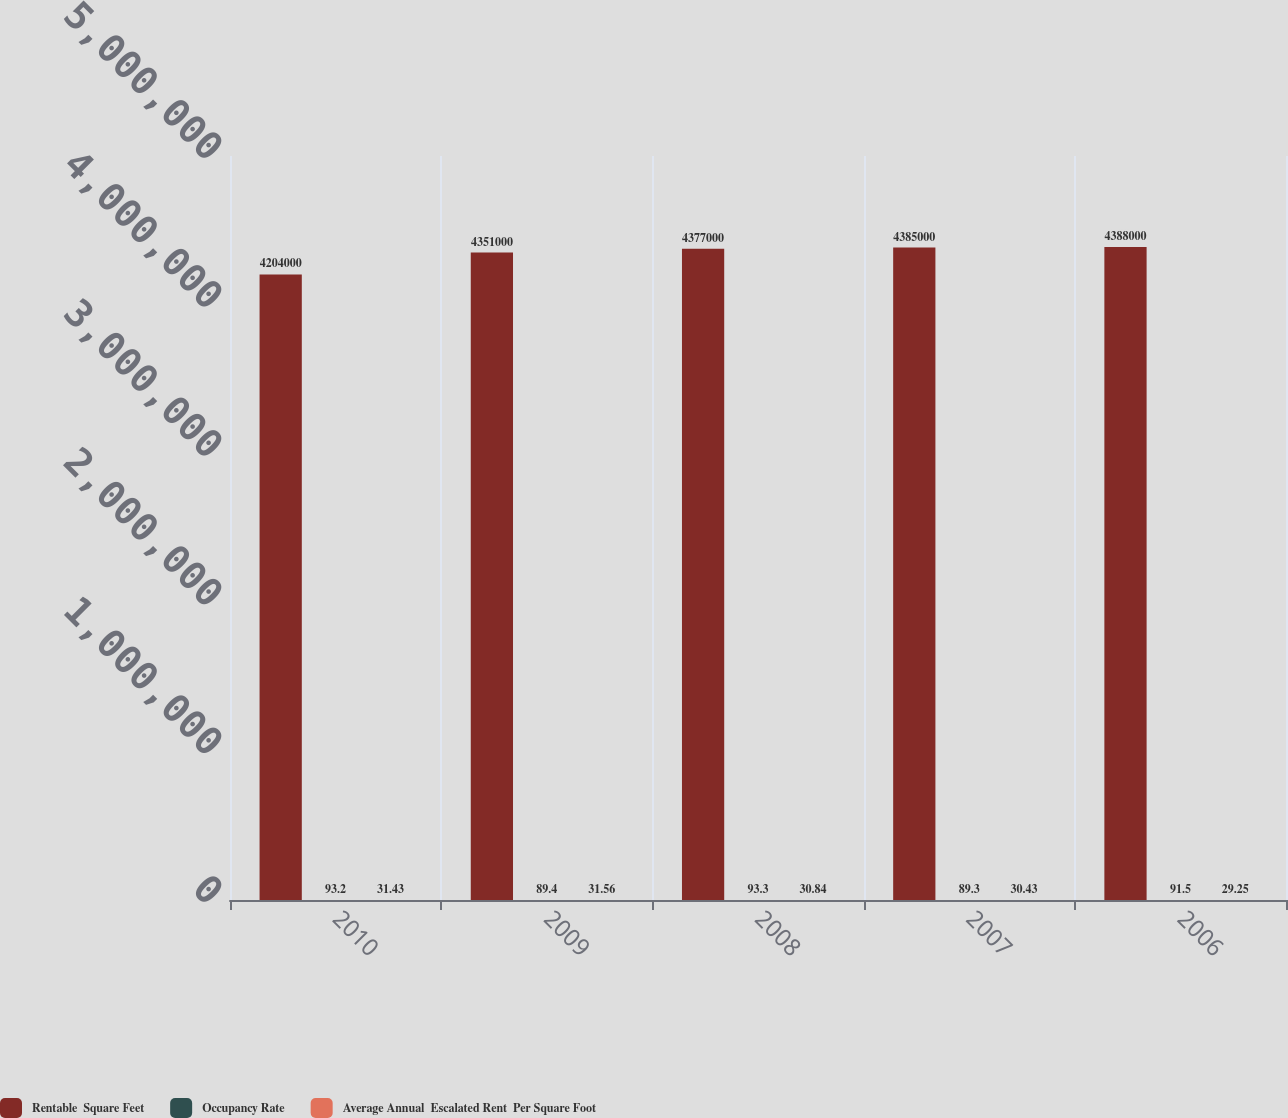Convert chart. <chart><loc_0><loc_0><loc_500><loc_500><stacked_bar_chart><ecel><fcel>2010<fcel>2009<fcel>2008<fcel>2007<fcel>2006<nl><fcel>Rentable  Square Feet<fcel>4.204e+06<fcel>4.351e+06<fcel>4.377e+06<fcel>4.385e+06<fcel>4.388e+06<nl><fcel>Occupancy Rate<fcel>93.2<fcel>89.4<fcel>93.3<fcel>89.3<fcel>91.5<nl><fcel>Average Annual  Escalated Rent  Per Square Foot<fcel>31.43<fcel>31.56<fcel>30.84<fcel>30.43<fcel>29.25<nl></chart> 